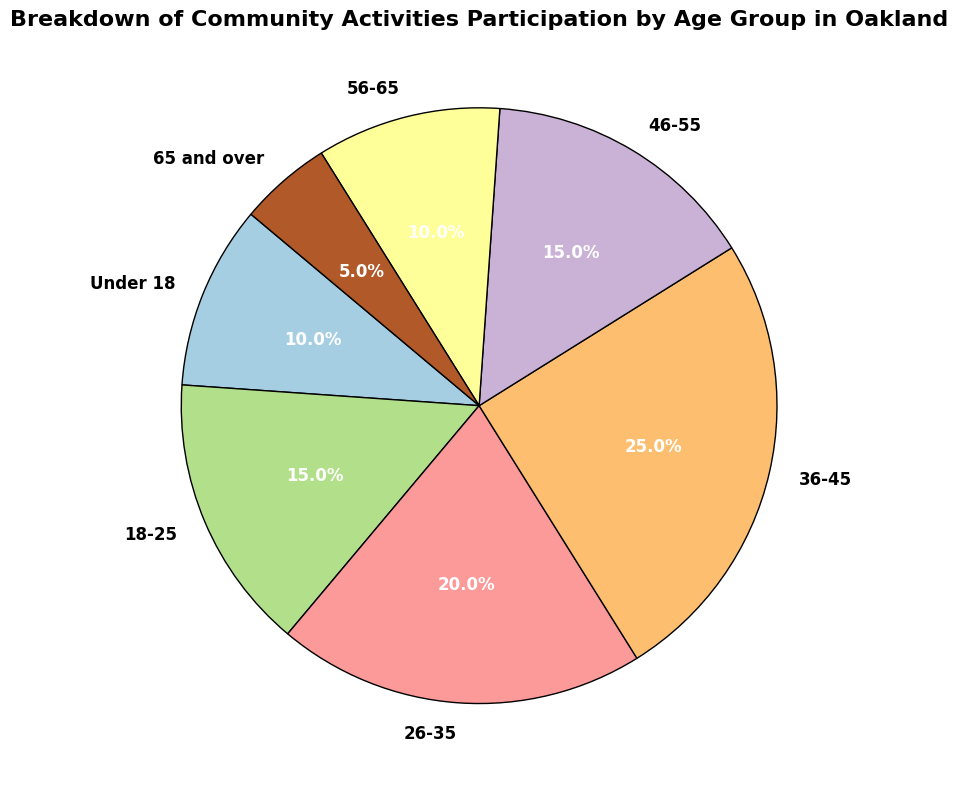What age group has the highest participation percentage in community activities? The pie chart shows that the age group with the highest participation percentage is 36-45 years. They occupy the largest section and have a label indicating 25%.
Answer: 36-45 years What are the total percentages of participation for age groups under 18 and 65 and over? Looking at the pie chart, the participation percentage for those under 18 is 10%, and for those 65 and over, it is 5%. Adding these gives 10% + 5% = 15%.
Answer: 15% Which age group has a equal participation percentage? Based on the pie chart, the age groups 18-25 and 46-55 each have a participation percentage of 15%.
Answer: 18-25 and 46-55 How much greater is the participation percentage of the 26-35 age group compared to the 65 and over age group? The participation percentage for the 26-35 age group is 20%, and for the 65 and over age group, it is 5%. The difference is 20% - 5% = 15%.
Answer: 15% What is the combined participation percentage for all age groups between 18 and 55? The age groups between 18 and 55 are 18-25, 26-35, 36-45, and 46-55. Their participation percentages are 15%, 20%, 25%, and 15%, respectively. Adding these gives 15% + 20% + 25% + 15% = 75%.
Answer: 75% Which age group has the smallest slice in the pie chart? Observing the pie chart, the smallest slice corresponds to the 65 and over age group, with a participation percentage of 5%.
Answer: 65 and over What is the difference in participation percentage between the age groups with the highest and lowest participation? The highest participation percentage is for the 36-45 age group at 25%, and the lowest is for the 65 and over age group at 5%. The difference is 25% - 5% = 20%.
Answer: 20% If you combine participation percentages for the age groups under 18, 56-65, and 65 and over, what is the total? The participation percentages are 10% for under 18, 10% for 56-65, and 5% for 65 and over. Summing these gives 10% + 10% + 5% = 25%.
Answer: 25% What is the sum of participation percentages for the age groups under 18 and 18-25? The participation percentage for under 18 is 10%, and for 18-25 it is 15%. Adding these gives 10% + 15% = 25%.
Answer: 25% What color represents the 26-35 age group in the pie chart? The pie chart uses a color palette that assigns different colors to each age group. The 26-35 age group is represented by a segment in likely shades of the palette, possibly turquoise or a related color.
Answer: Turquoise 